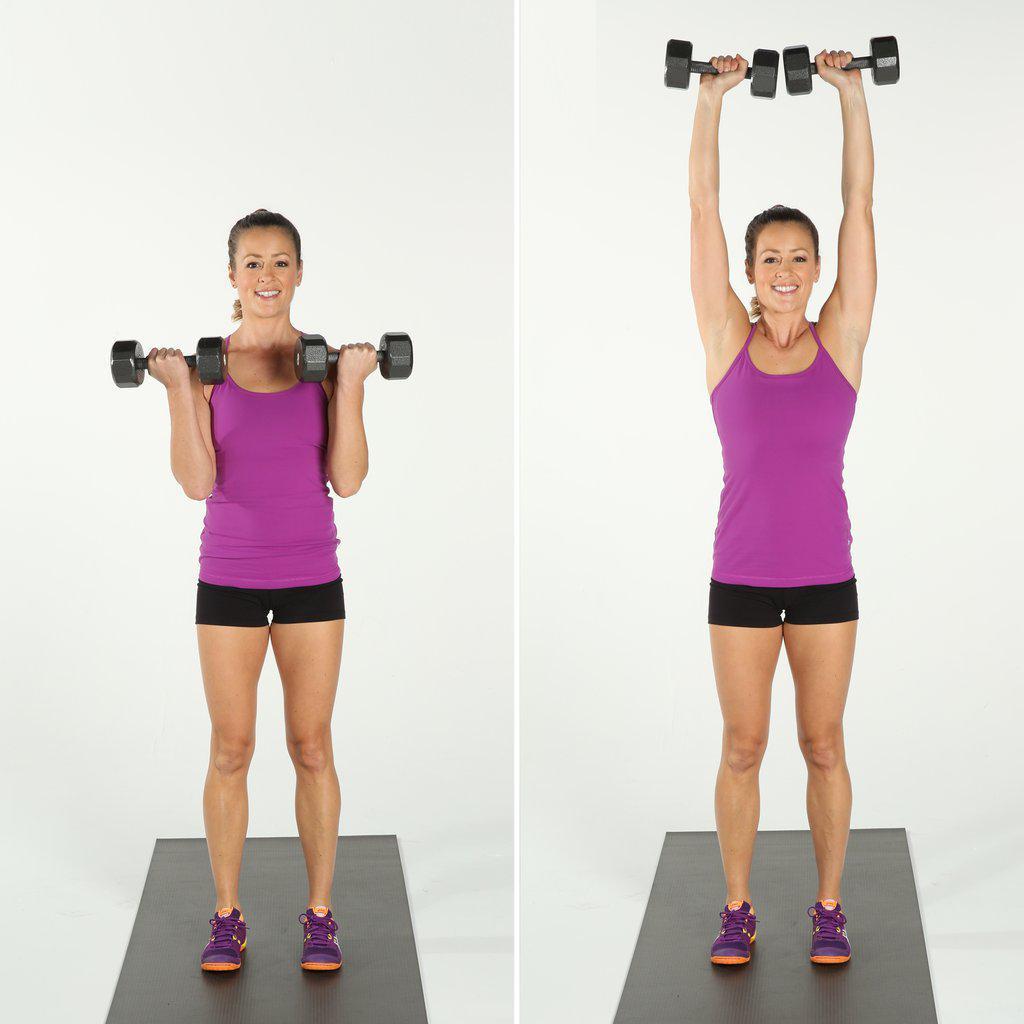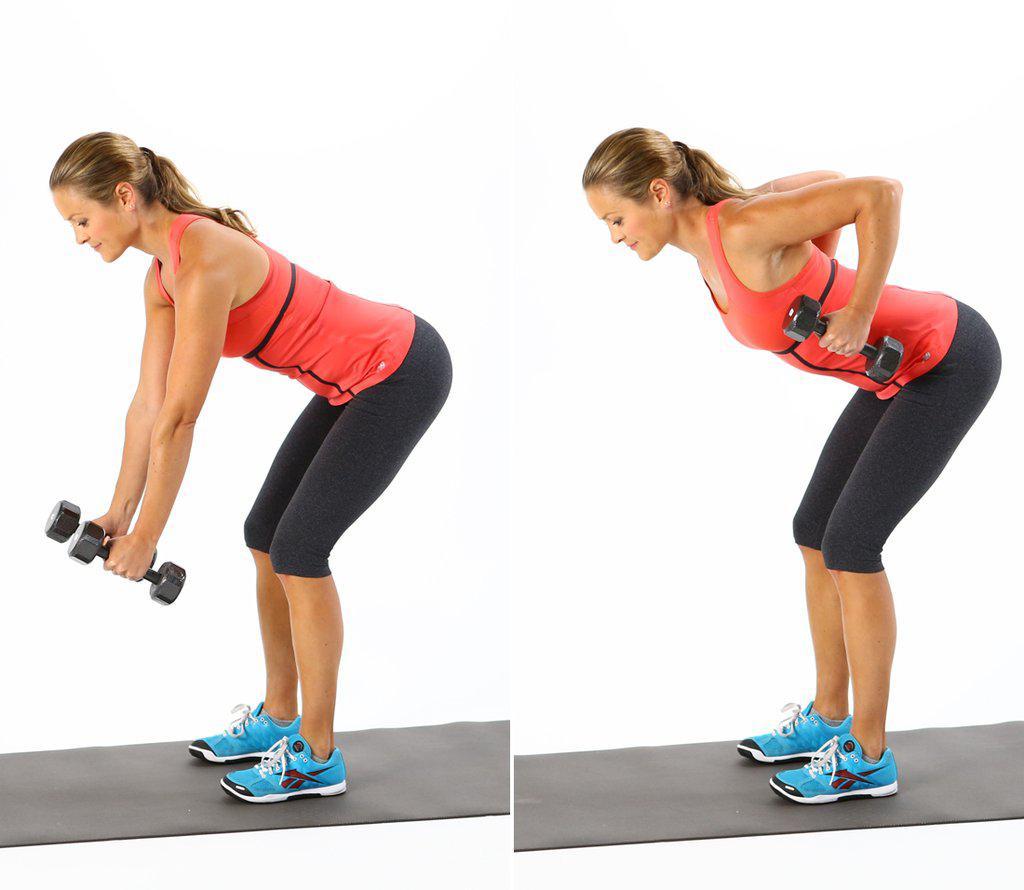The first image is the image on the left, the second image is the image on the right. For the images displayed, is the sentence "The left image shows a female working out." factually correct? Answer yes or no. Yes. 